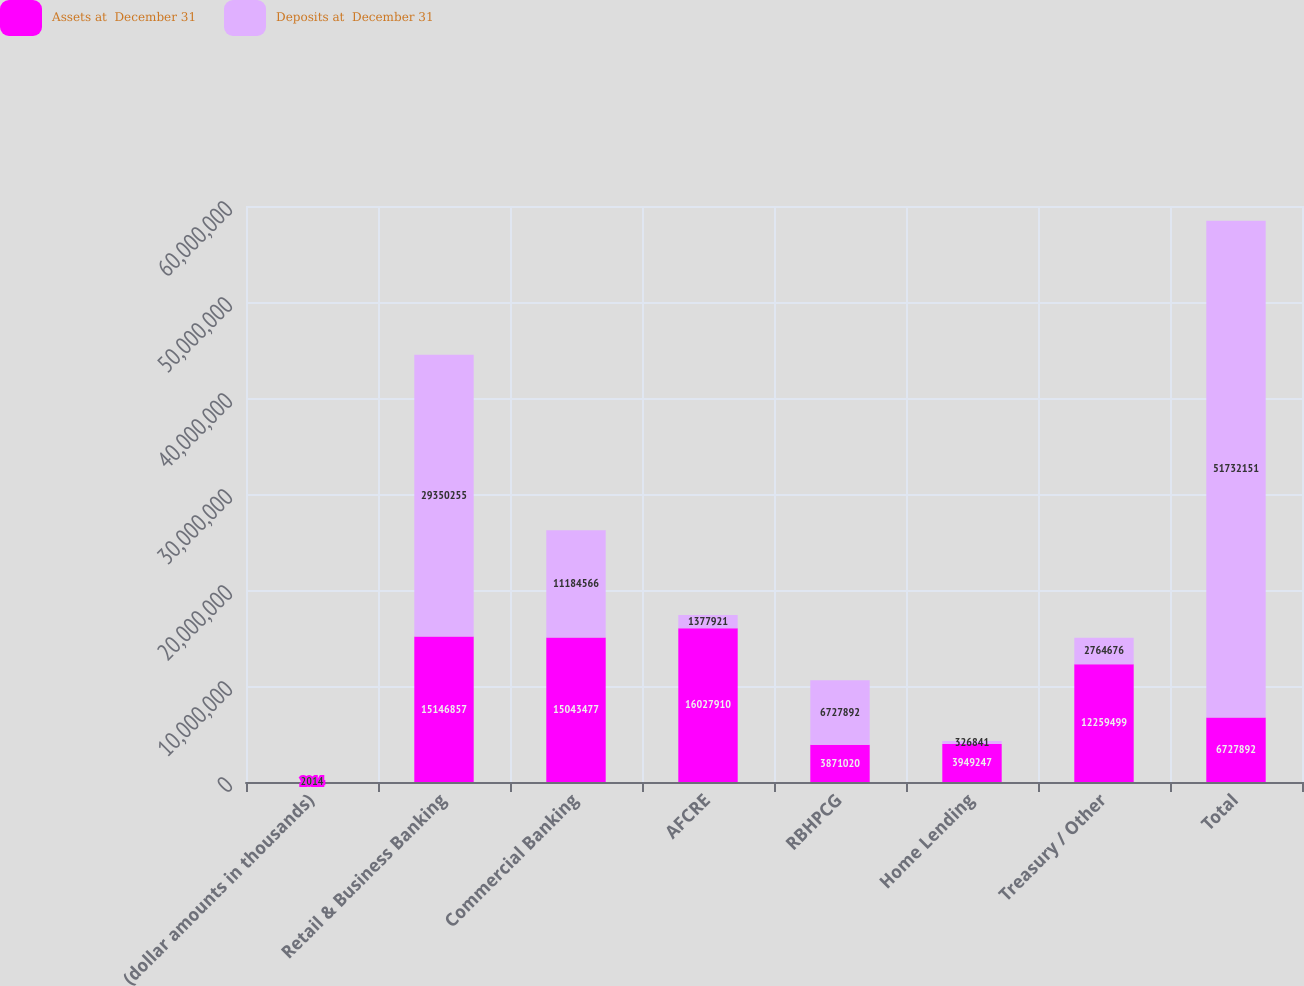Convert chart. <chart><loc_0><loc_0><loc_500><loc_500><stacked_bar_chart><ecel><fcel>(dollar amounts in thousands)<fcel>Retail & Business Banking<fcel>Commercial Banking<fcel>AFCRE<fcel>RBHPCG<fcel>Home Lending<fcel>Treasury / Other<fcel>Total<nl><fcel>Assets at  December 31<fcel>2014<fcel>1.51469e+07<fcel>1.50435e+07<fcel>1.60279e+07<fcel>3.87102e+06<fcel>3.94925e+06<fcel>1.22595e+07<fcel>6.72789e+06<nl><fcel>Deposits at  December 31<fcel>2014<fcel>2.93503e+07<fcel>1.11846e+07<fcel>1.37792e+06<fcel>6.72789e+06<fcel>326841<fcel>2.76468e+06<fcel>5.17322e+07<nl></chart> 